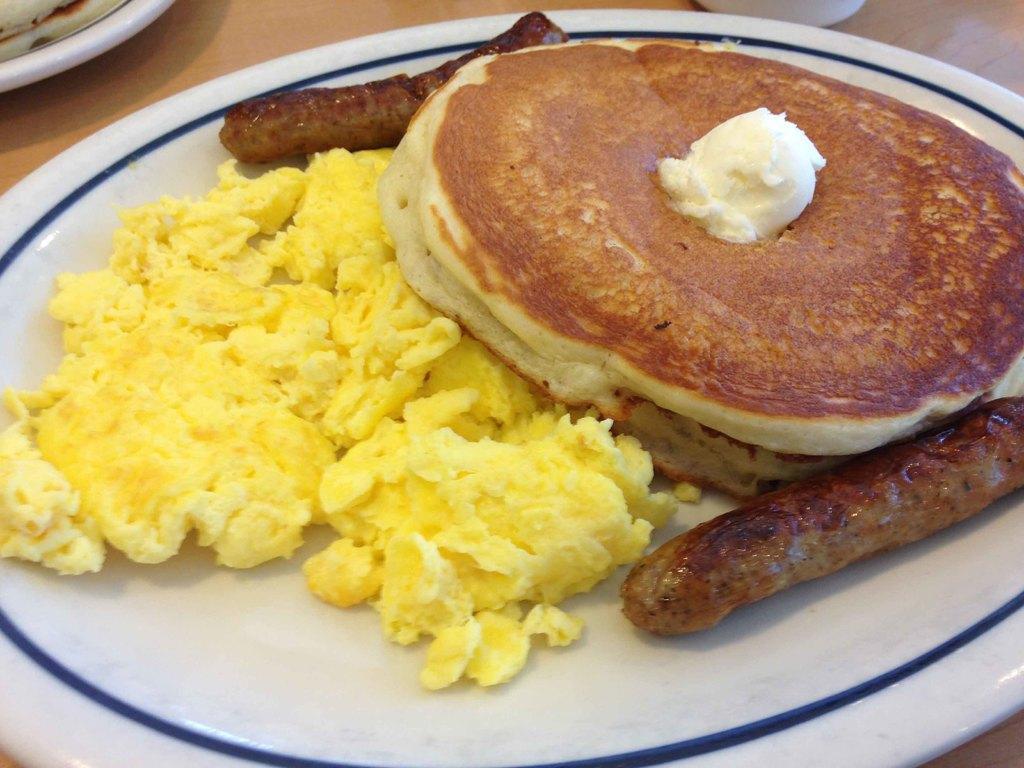In one or two sentences, can you explain what this image depicts? In this image I can see plates on a table in which food items are there. This image is taken may be in a room. 